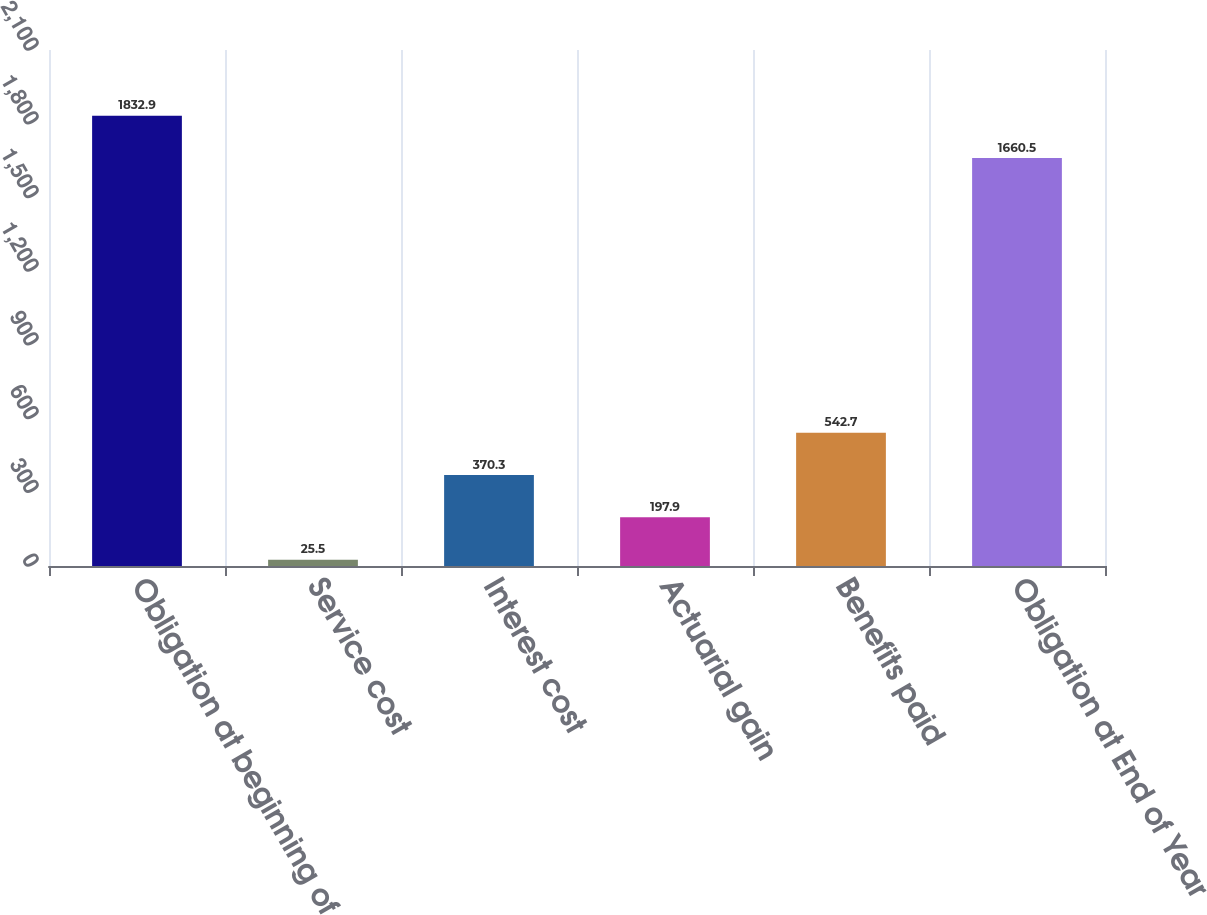Convert chart to OTSL. <chart><loc_0><loc_0><loc_500><loc_500><bar_chart><fcel>Obligation at beginning of<fcel>Service cost<fcel>Interest cost<fcel>Actuarial gain<fcel>Benefits paid<fcel>Obligation at End of Year<nl><fcel>1832.9<fcel>25.5<fcel>370.3<fcel>197.9<fcel>542.7<fcel>1660.5<nl></chart> 